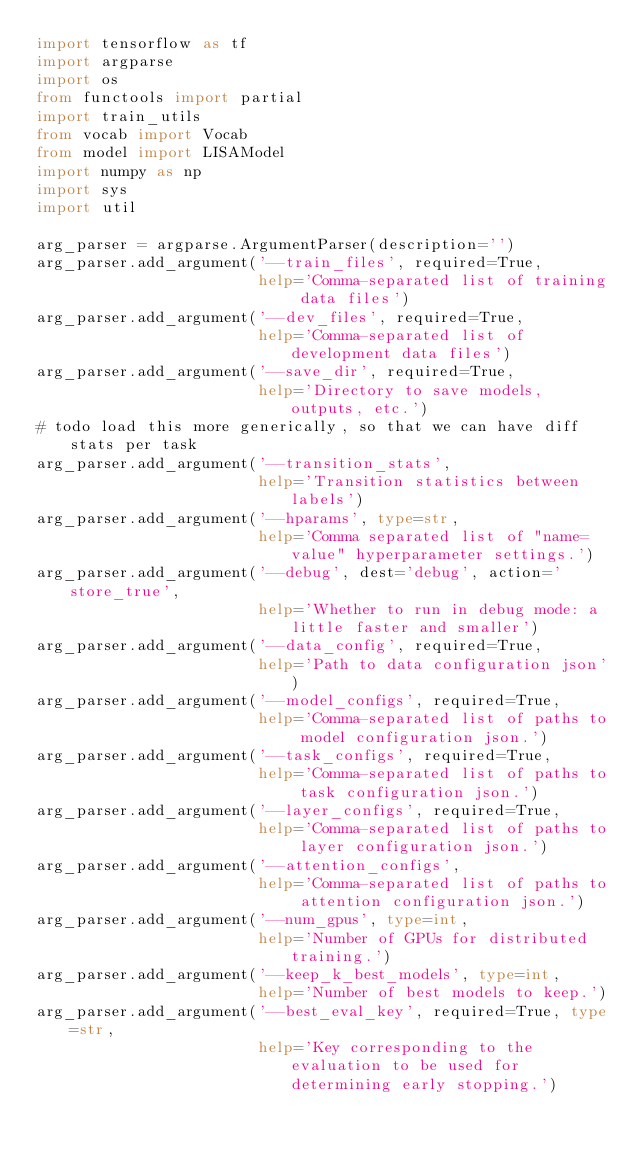Convert code to text. <code><loc_0><loc_0><loc_500><loc_500><_Python_>import tensorflow as tf
import argparse
import os
from functools import partial
import train_utils
from vocab import Vocab
from model import LISAModel
import numpy as np
import sys
import util

arg_parser = argparse.ArgumentParser(description='')
arg_parser.add_argument('--train_files', required=True,
                        help='Comma-separated list of training data files')
arg_parser.add_argument('--dev_files', required=True,
                        help='Comma-separated list of development data files')
arg_parser.add_argument('--save_dir', required=True,
                        help='Directory to save models, outputs, etc.')
# todo load this more generically, so that we can have diff stats per task
arg_parser.add_argument('--transition_stats',
                        help='Transition statistics between labels')
arg_parser.add_argument('--hparams', type=str,
                        help='Comma separated list of "name=value" hyperparameter settings.')
arg_parser.add_argument('--debug', dest='debug', action='store_true',
                        help='Whether to run in debug mode: a little faster and smaller')
arg_parser.add_argument('--data_config', required=True,
                        help='Path to data configuration json')
arg_parser.add_argument('--model_configs', required=True,
                        help='Comma-separated list of paths to model configuration json.')
arg_parser.add_argument('--task_configs', required=True,
                        help='Comma-separated list of paths to task configuration json.')
arg_parser.add_argument('--layer_configs', required=True,
                        help='Comma-separated list of paths to layer configuration json.')
arg_parser.add_argument('--attention_configs',
                        help='Comma-separated list of paths to attention configuration json.')
arg_parser.add_argument('--num_gpus', type=int,
                        help='Number of GPUs for distributed training.')
arg_parser.add_argument('--keep_k_best_models', type=int,
                        help='Number of best models to keep.')
arg_parser.add_argument('--best_eval_key', required=True, type=str,
                        help='Key corresponding to the evaluation to be used for determining early stopping.')
</code> 